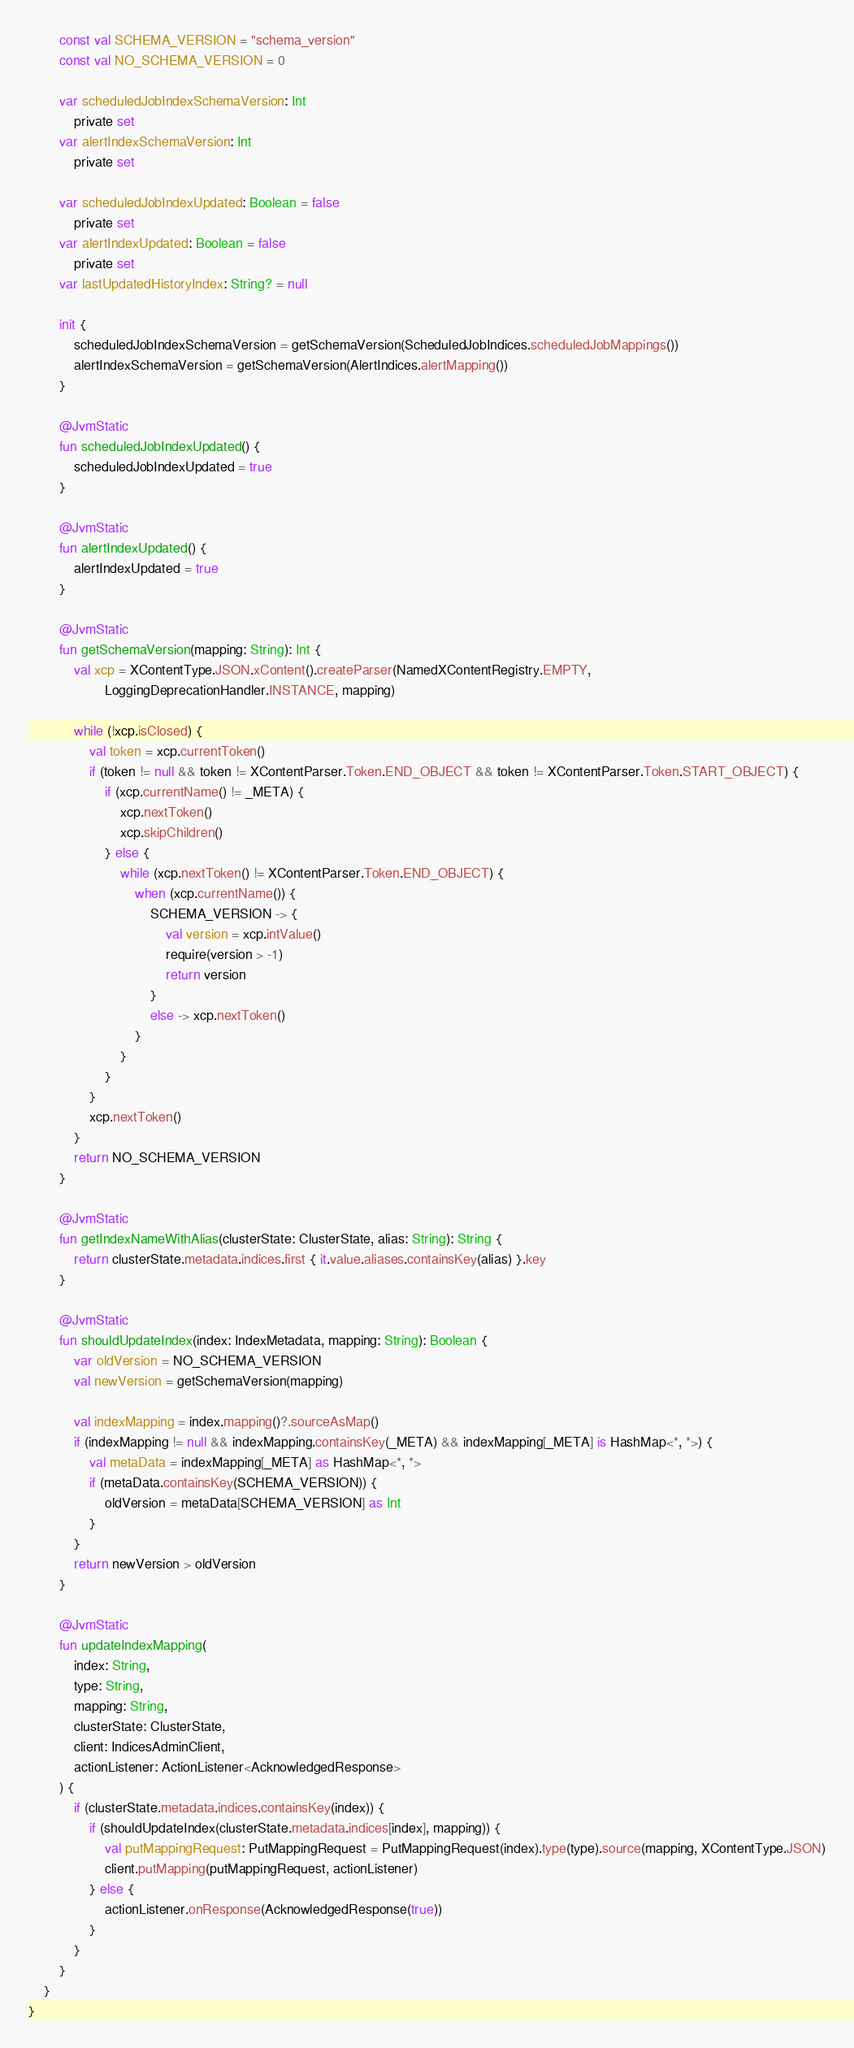Convert code to text. <code><loc_0><loc_0><loc_500><loc_500><_Kotlin_>        const val SCHEMA_VERSION = "schema_version"
        const val NO_SCHEMA_VERSION = 0

        var scheduledJobIndexSchemaVersion: Int
            private set
        var alertIndexSchemaVersion: Int
            private set

        var scheduledJobIndexUpdated: Boolean = false
            private set
        var alertIndexUpdated: Boolean = false
            private set
        var lastUpdatedHistoryIndex: String? = null

        init {
            scheduledJobIndexSchemaVersion = getSchemaVersion(ScheduledJobIndices.scheduledJobMappings())
            alertIndexSchemaVersion = getSchemaVersion(AlertIndices.alertMapping())
        }

        @JvmStatic
        fun scheduledJobIndexUpdated() {
            scheduledJobIndexUpdated = true
        }

        @JvmStatic
        fun alertIndexUpdated() {
            alertIndexUpdated = true
        }

        @JvmStatic
        fun getSchemaVersion(mapping: String): Int {
            val xcp = XContentType.JSON.xContent().createParser(NamedXContentRegistry.EMPTY,
                    LoggingDeprecationHandler.INSTANCE, mapping)

            while (!xcp.isClosed) {
                val token = xcp.currentToken()
                if (token != null && token != XContentParser.Token.END_OBJECT && token != XContentParser.Token.START_OBJECT) {
                    if (xcp.currentName() != _META) {
                        xcp.nextToken()
                        xcp.skipChildren()
                    } else {
                        while (xcp.nextToken() != XContentParser.Token.END_OBJECT) {
                            when (xcp.currentName()) {
                                SCHEMA_VERSION -> {
                                    val version = xcp.intValue()
                                    require(version > -1)
                                    return version
                                }
                                else -> xcp.nextToken()
                            }
                        }
                    }
                }
                xcp.nextToken()
            }
            return NO_SCHEMA_VERSION
        }

        @JvmStatic
        fun getIndexNameWithAlias(clusterState: ClusterState, alias: String): String {
            return clusterState.metadata.indices.first { it.value.aliases.containsKey(alias) }.key
        }

        @JvmStatic
        fun shouldUpdateIndex(index: IndexMetadata, mapping: String): Boolean {
            var oldVersion = NO_SCHEMA_VERSION
            val newVersion = getSchemaVersion(mapping)

            val indexMapping = index.mapping()?.sourceAsMap()
            if (indexMapping != null && indexMapping.containsKey(_META) && indexMapping[_META] is HashMap<*, *>) {
                val metaData = indexMapping[_META] as HashMap<*, *>
                if (metaData.containsKey(SCHEMA_VERSION)) {
                    oldVersion = metaData[SCHEMA_VERSION] as Int
                }
            }
            return newVersion > oldVersion
        }

        @JvmStatic
        fun updateIndexMapping(
            index: String,
            type: String,
            mapping: String,
            clusterState: ClusterState,
            client: IndicesAdminClient,
            actionListener: ActionListener<AcknowledgedResponse>
        ) {
            if (clusterState.metadata.indices.containsKey(index)) {
                if (shouldUpdateIndex(clusterState.metadata.indices[index], mapping)) {
                    val putMappingRequest: PutMappingRequest = PutMappingRequest(index).type(type).source(mapping, XContentType.JSON)
                    client.putMapping(putMappingRequest, actionListener)
                } else {
                    actionListener.onResponse(AcknowledgedResponse(true))
                }
            }
        }
    }
}
</code> 